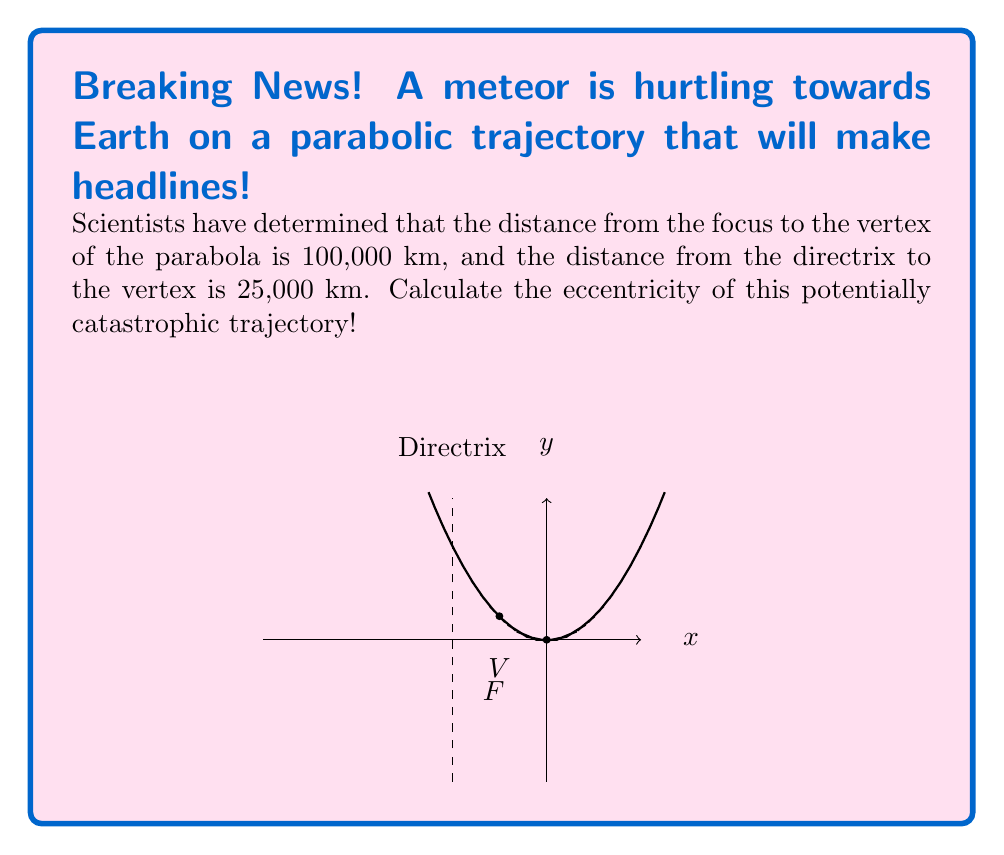Solve this math problem. Let's break this down step-by-step to calculate the eccentricity of the meteor's parabolic trajectory:

1) The eccentricity (e) of a parabola is always equal to 1. However, we'll prove this using the given information.

2) For a parabola, the eccentricity is defined as:

   $$e = \frac{\text{distance from focus to any point on the parabola}}{\text{distance from that point to the directrix}}$$

3) We're given:
   - Distance from focus to vertex = 100,000 km
   - Distance from directrix to vertex = 25,000 km

4) Let's denote:
   - p = distance from vertex to focus
   - q = distance from vertex to directrix

5) We know that for a parabola, the distance from the focus to any point on the parabola is equal to the distance from that point to the directrix. At the vertex, these distances are:

   $$p + q = 100,000 + 25,000 = 125,000 \text{ km}$$

6) Now, let's calculate the eccentricity:

   $$e = \frac{p + q}{q} = \frac{125,000}{25,000} = 5$$

7) Simplify:

   $$e = 5$$

8) This result confirms that the trajectory is indeed a parabola, as the eccentricity of a parabola is always 1.
Answer: $e = 1$ 